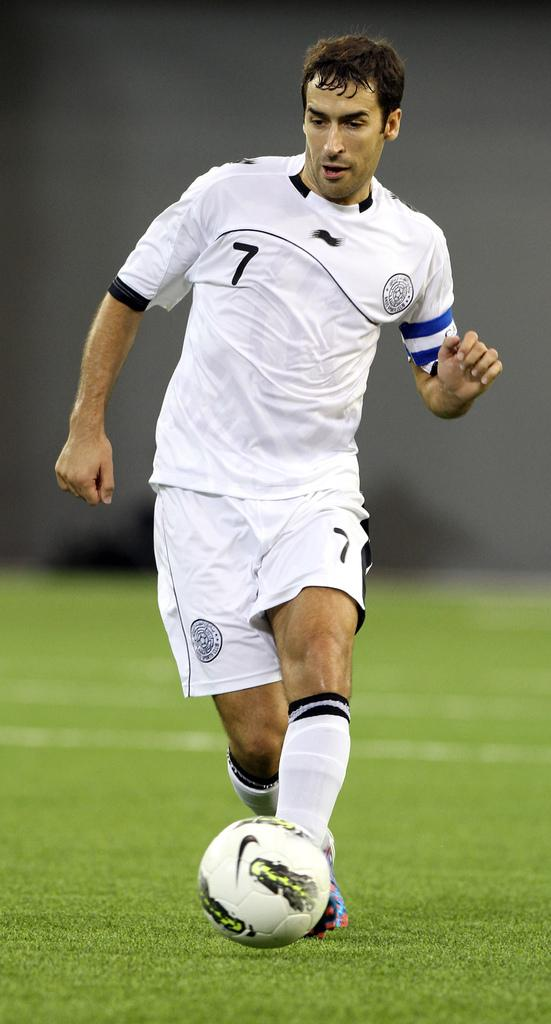Who is present in the image? There is a man in the image. What is the man doing in the image? The man is standing and playing with a football. What is the surface beneath the man's feet? The ground is covered with grass. What type of leather is the man wearing in the image? There is no mention of leather in the image, and the man is not wearing any clothing that would be made of leather. 